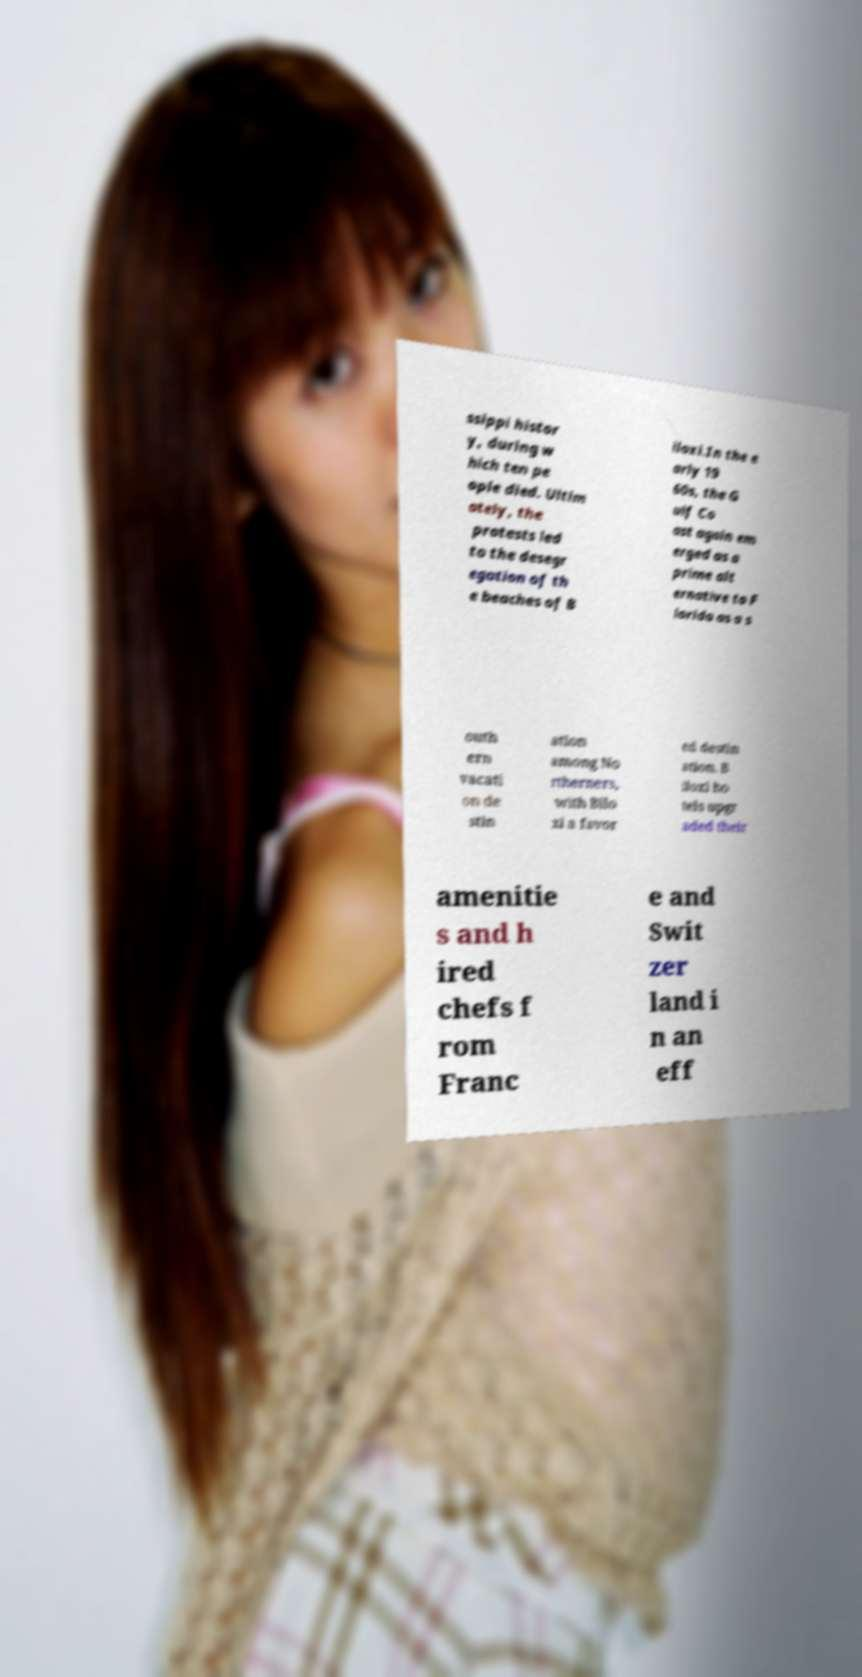Can you read and provide the text displayed in the image?This photo seems to have some interesting text. Can you extract and type it out for me? ssippi histor y, during w hich ten pe ople died. Ultim ately, the protests led to the desegr egation of th e beaches of B iloxi.In the e arly 19 60s, the G ulf Co ast again em erged as a prime alt ernative to F lorida as a s outh ern vacati on de stin ation among No rtherners, with Bilo xi a favor ed destin ation. B iloxi ho tels upgr aded their amenitie s and h ired chefs f rom Franc e and Swit zer land i n an eff 